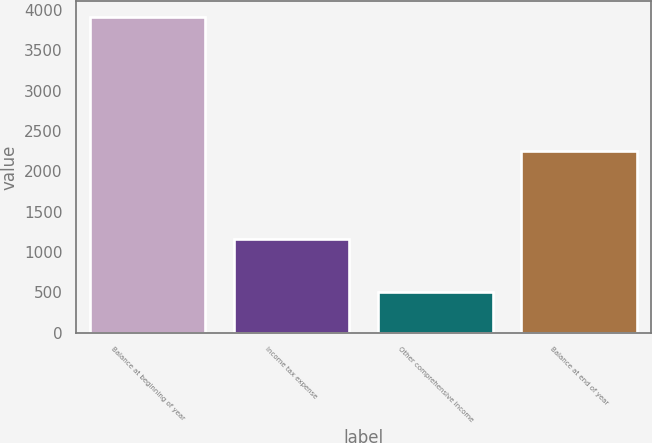Convert chart to OTSL. <chart><loc_0><loc_0><loc_500><loc_500><bar_chart><fcel>Balance at beginning of year<fcel>Income tax expense<fcel>Other comprehensive income<fcel>Balance at end of year<nl><fcel>3912<fcel>1155<fcel>505<fcel>2252<nl></chart> 